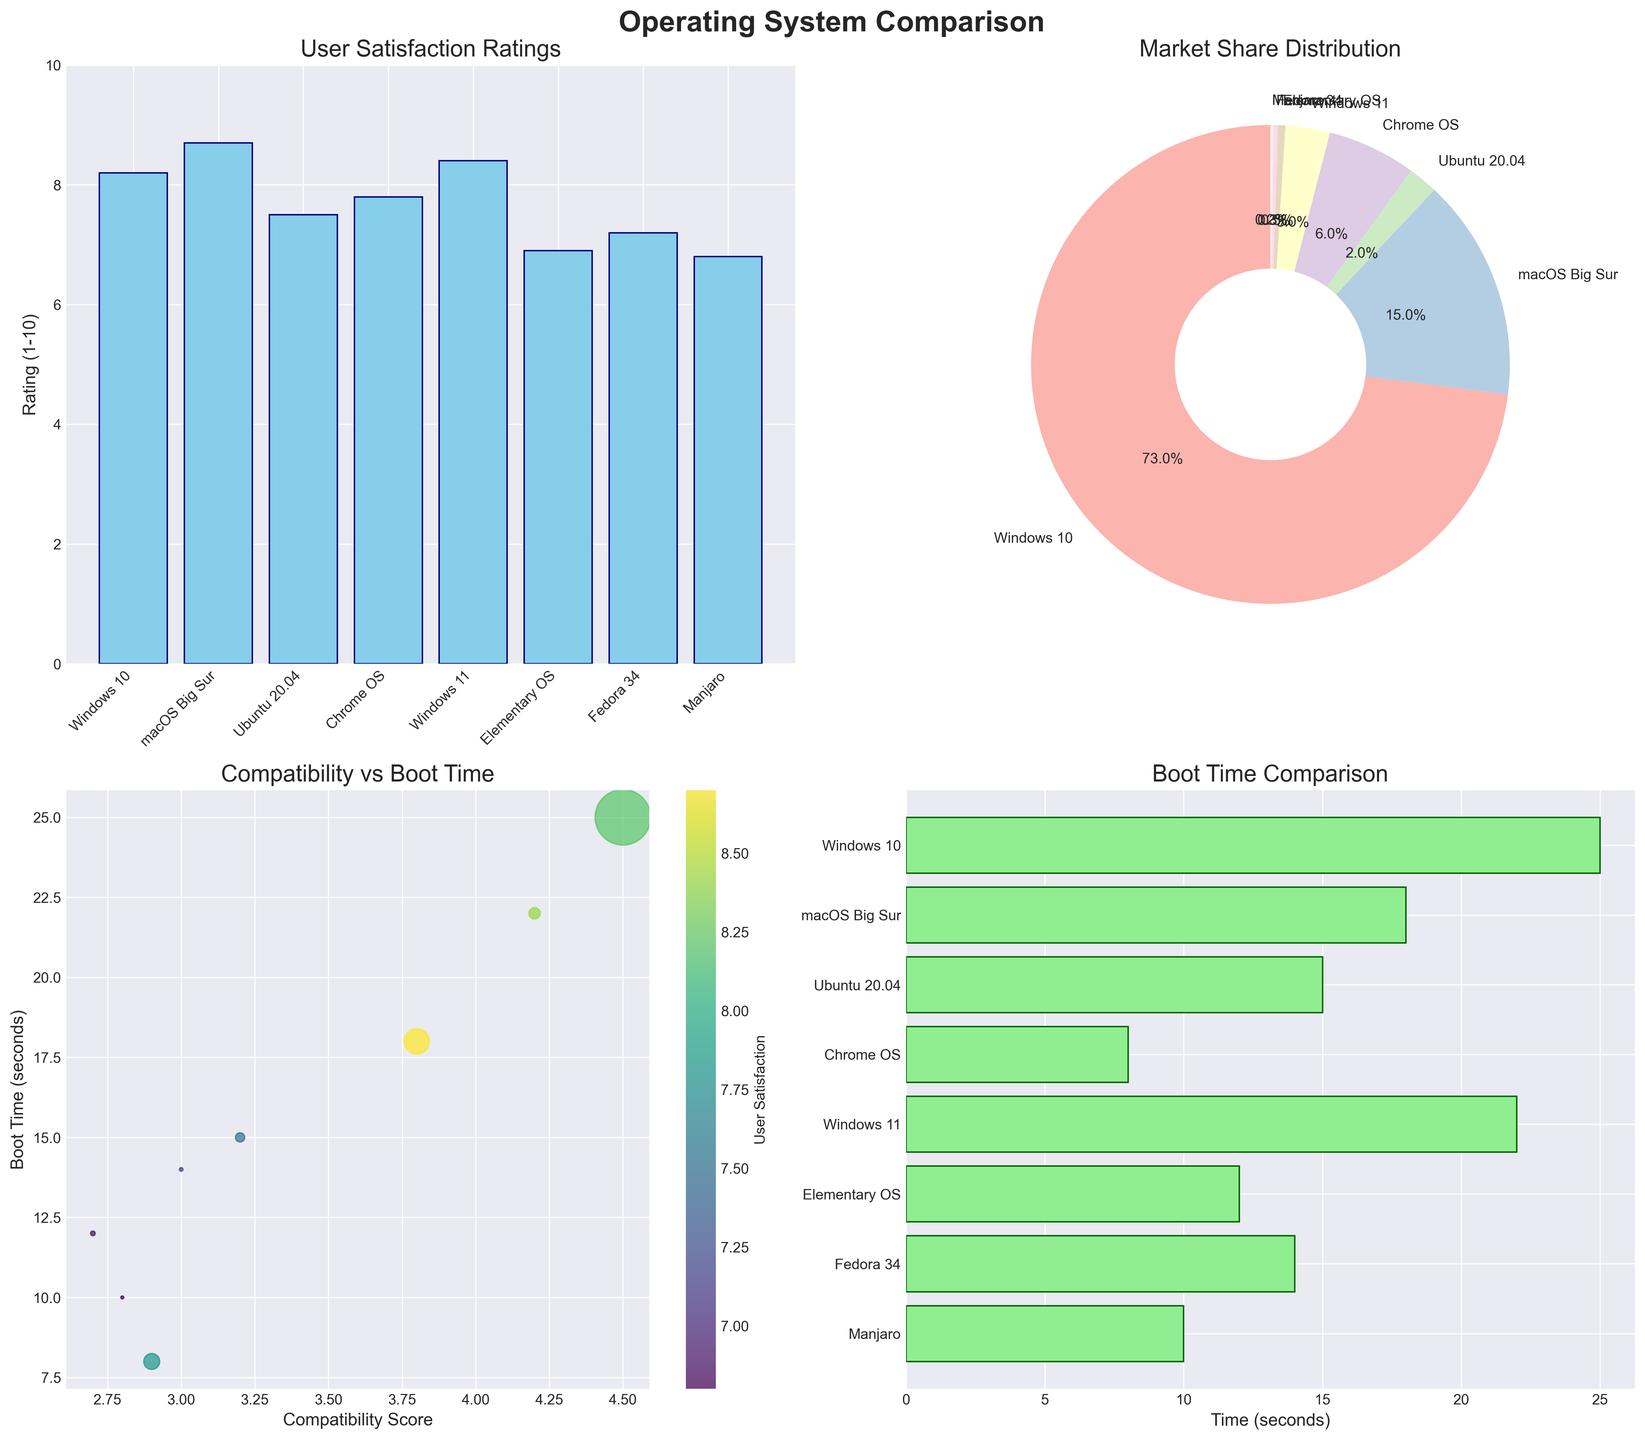Which operating system has the highest user satisfaction rating? The highest bar in the "User Satisfaction Ratings" subplot corresponds to macOS Big Sur, with a rating of 8.7
Answer: macOS Big Sur What is the market share of Windows 10? In the "Market Share Distribution" pie chart, refer to the segment labeled Windows 10, which shows 73.0%
Answer: 73.0% How does the boot time of Chrome OS compare to Manjaro? In the "Boot Time Comparison" subplot, Chrome OS has a boot time of 8 seconds, while Manjaro has a boot time of 10 seconds. Thus, Chrome OS boots faster by 2 seconds
Answer: Chrome OS boots faster by 2 seconds Which operating system has the lowest compatibility score? In the "Compatibility vs Boot Time" scatter plot, Elementary OS and Manjaro are the lowest on the x-axis (Compatibility Score of 2.7 and 2.8, respectively), with Elementary OS being slightly lower
Answer: Elementary OS What is the average user satisfaction rating across all operating systems? Sum all user satisfaction ratings (8.2 + 8.7 + 7.5 + 7.8 + 8.4 + 6.9 + 7.2 + 6.8) = 61.5, and then divide by the number of operating systems (8)
Answer: 7.7 Which operating system has the fastest boot time? The shortest bar in the "Boot Time Comparison" subplot corresponds to Chrome OS, with a boot time of 8 seconds
Answer: Chrome OS Can you compare the user satisfaction ratings of Windows 10 and Ubuntu 20.04? In the "User Satisfaction Ratings" subplot, the bar for Windows 10 shows a rating of 8.2, while the bar for Ubuntu 20.04 shows a rating of 7.5. Windows 10 has a higher rating than Ubuntu 20.04 by 0.7
Answer: Windows 10 has a higher rating by 0.7 What's the correlation between compatibility score and boot time? By observing the scatter plot "Compatibility vs Boot Time," there is no clear linear pattern between compatibility scores (1-5) and boot times (seconds). The points are scattered without a clear trend
Answer: No clear correlation Which operating systems have a compatibility score higher than 4? In the "Compatibility vs Boot Time" scatter plot, observe points where the compatibility score on the x-axis is higher than 4: Windows 10 (4.5) and Windows 11 (4.2)
Answer: Windows 10, Windows 11 